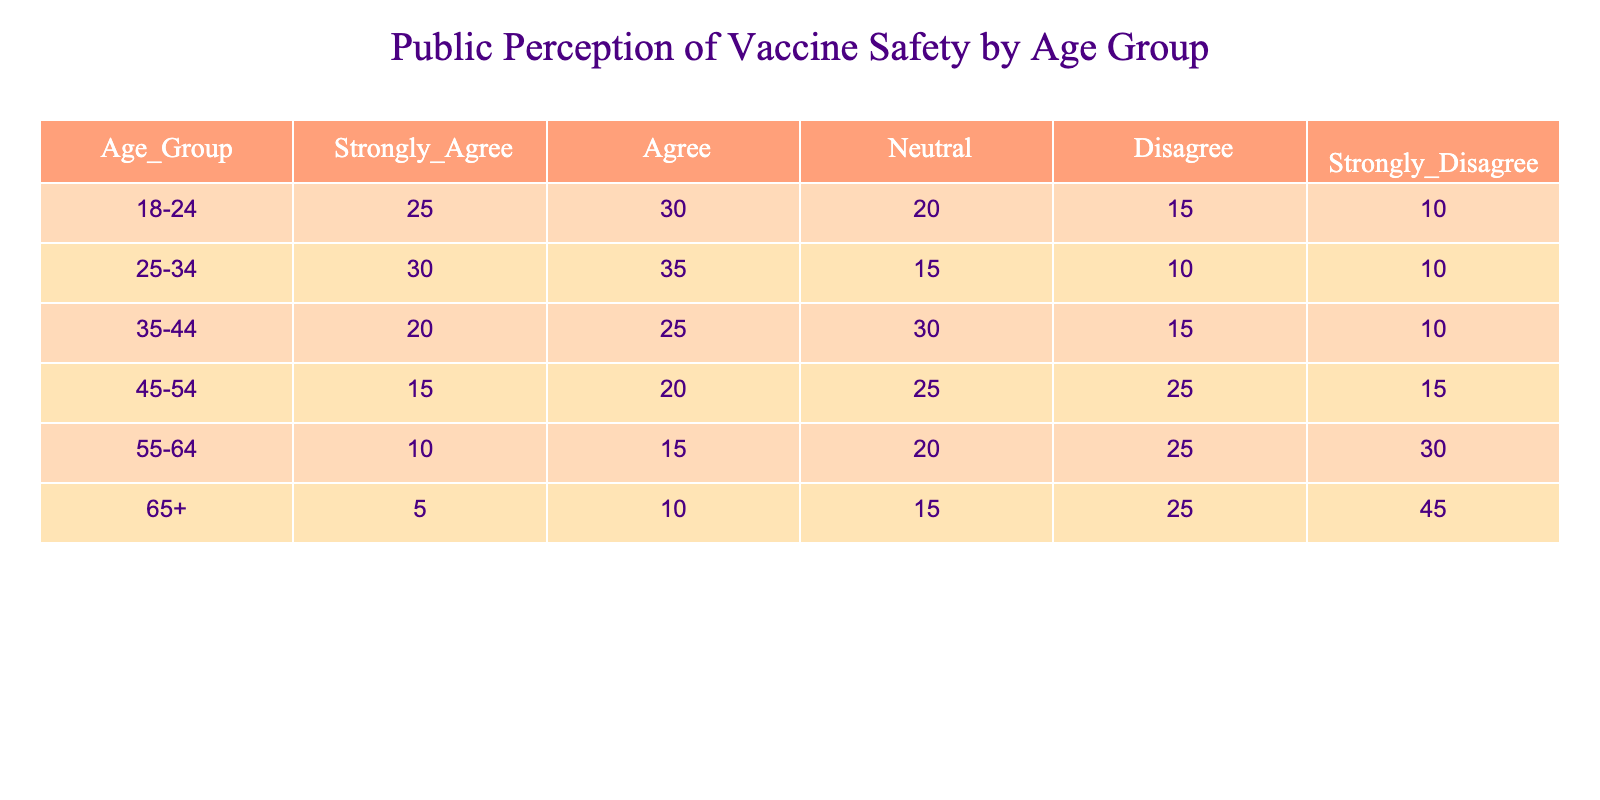What percentage of respondents aged 18-24 strongly agree that the vaccine is safe? There are a total of 110 responses in the 18-24 age group (25 + 30 + 20 + 15 + 10 = 110). The number of respondents who strongly agree is 25. To find the percentage, divide 25 by 110 and multiply by 100, giving (25/110) * 100 ≈ 22.73%.
Answer: 22.73% Which age group has the highest number of respondents who disagree with the vaccine safety? In the table, the age groups and their "Disagree" counts are as follows: 18-24 (15), 25-34 (10), 35-44 (15), 45-54 (25), 55-64 (25), and 65+ (25). The highest count among these is 25, occurring in the 45-54, 55-64, and 65+ age groups.
Answer: 45-54, 55-64, and 65+ Is it true that the majority of the 65+ age group strongly agrees that the vaccine is safe? In the 65+ age group, only 5 respondents strongly agree with the vaccine safety out of 100 total respondents (5 + 10 + 15 + 25 + 45 = 100). Since 5 is not more than half of 100, it is false.
Answer: No What is the total number of respondents who are neutral across all age groups? By adding up the "Neutral" responses from all age groups: 20 (18-24) + 15 (25-34) + 30 (35-44) + 25 (45-54) + 20 (55-64) + 15 (65+) = 125. Thus, the total number of neutral respondents is 125.
Answer: 125 What is the difference in the "Strongly Disagree" responses between the 55-64 and 65+ age groups? The "Strongly Disagree" responses are 30 for the 55-64 age group and 45 for the 65+ age group. To find the difference, subtract: 45 - 30 = 15.
Answer: 15 